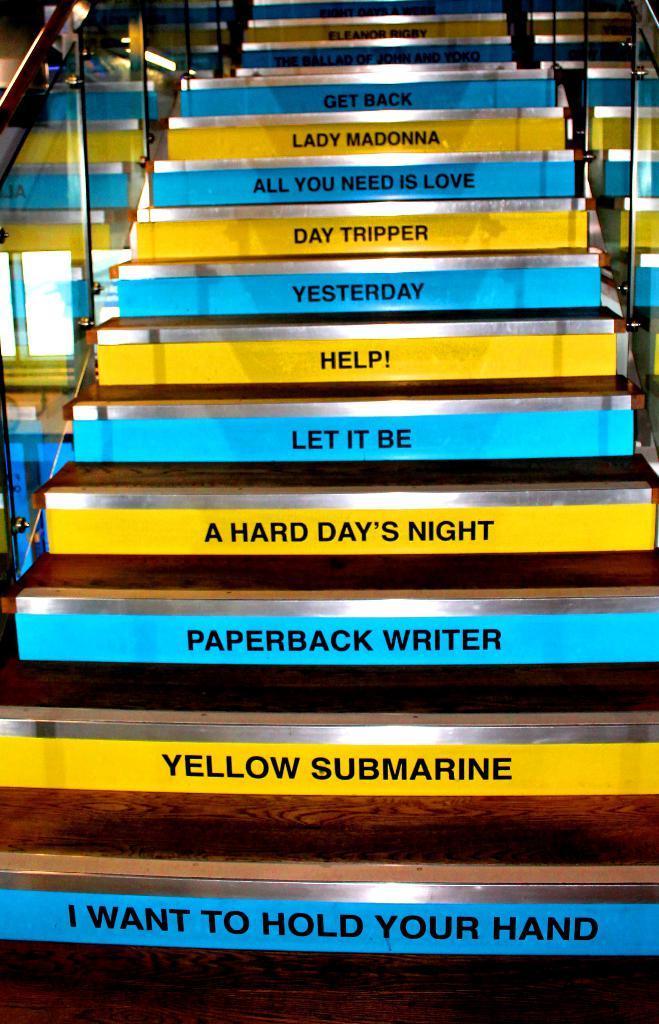What do the steps say?
Provide a succinct answer. I want to hold your hand, yellow submarine, paperback writer, a hard day's night, let it be, help, yesterday, day tripper all you need is love, lady madonna, get back. 